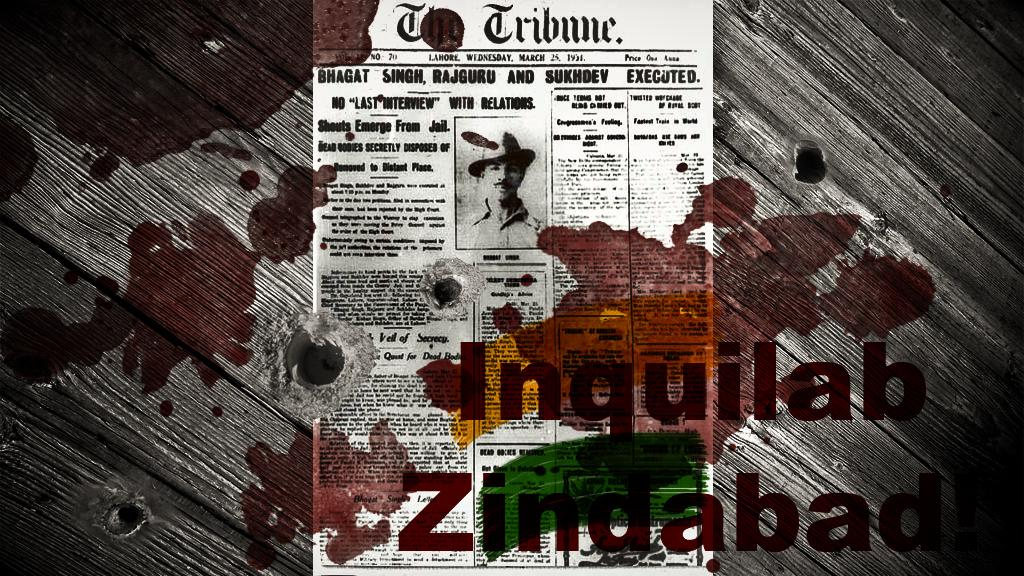<image>
Offer a succinct explanation of the picture presented. a paper that says 'the tribune' at the top of it 